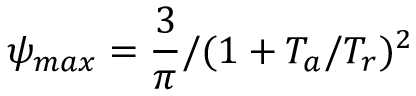<formula> <loc_0><loc_0><loc_500><loc_500>{ \psi } _ { \max } = { \frac { 3 } { \pi } } / ( 1 + T _ { a } / T _ { r } ) ^ { 2 }</formula> 